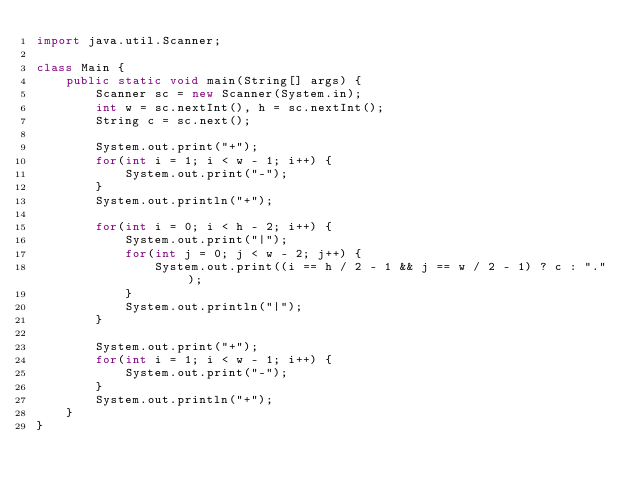<code> <loc_0><loc_0><loc_500><loc_500><_Java_>import java.util.Scanner;

class Main {
    public static void main(String[] args) {
        Scanner sc = new Scanner(System.in);
        int w = sc.nextInt(), h = sc.nextInt();
        String c = sc.next();

        System.out.print("+");
        for(int i = 1; i < w - 1; i++) {
            System.out.print("-");
        }
        System.out.println("+");

        for(int i = 0; i < h - 2; i++) {
            System.out.print("|");
            for(int j = 0; j < w - 2; j++) {
                System.out.print((i == h / 2 - 1 && j == w / 2 - 1) ? c : ".");
            }
            System.out.println("|");
        }

        System.out.print("+");
        for(int i = 1; i < w - 1; i++) {
            System.out.print("-");
        }
        System.out.println("+");
    }
}</code> 